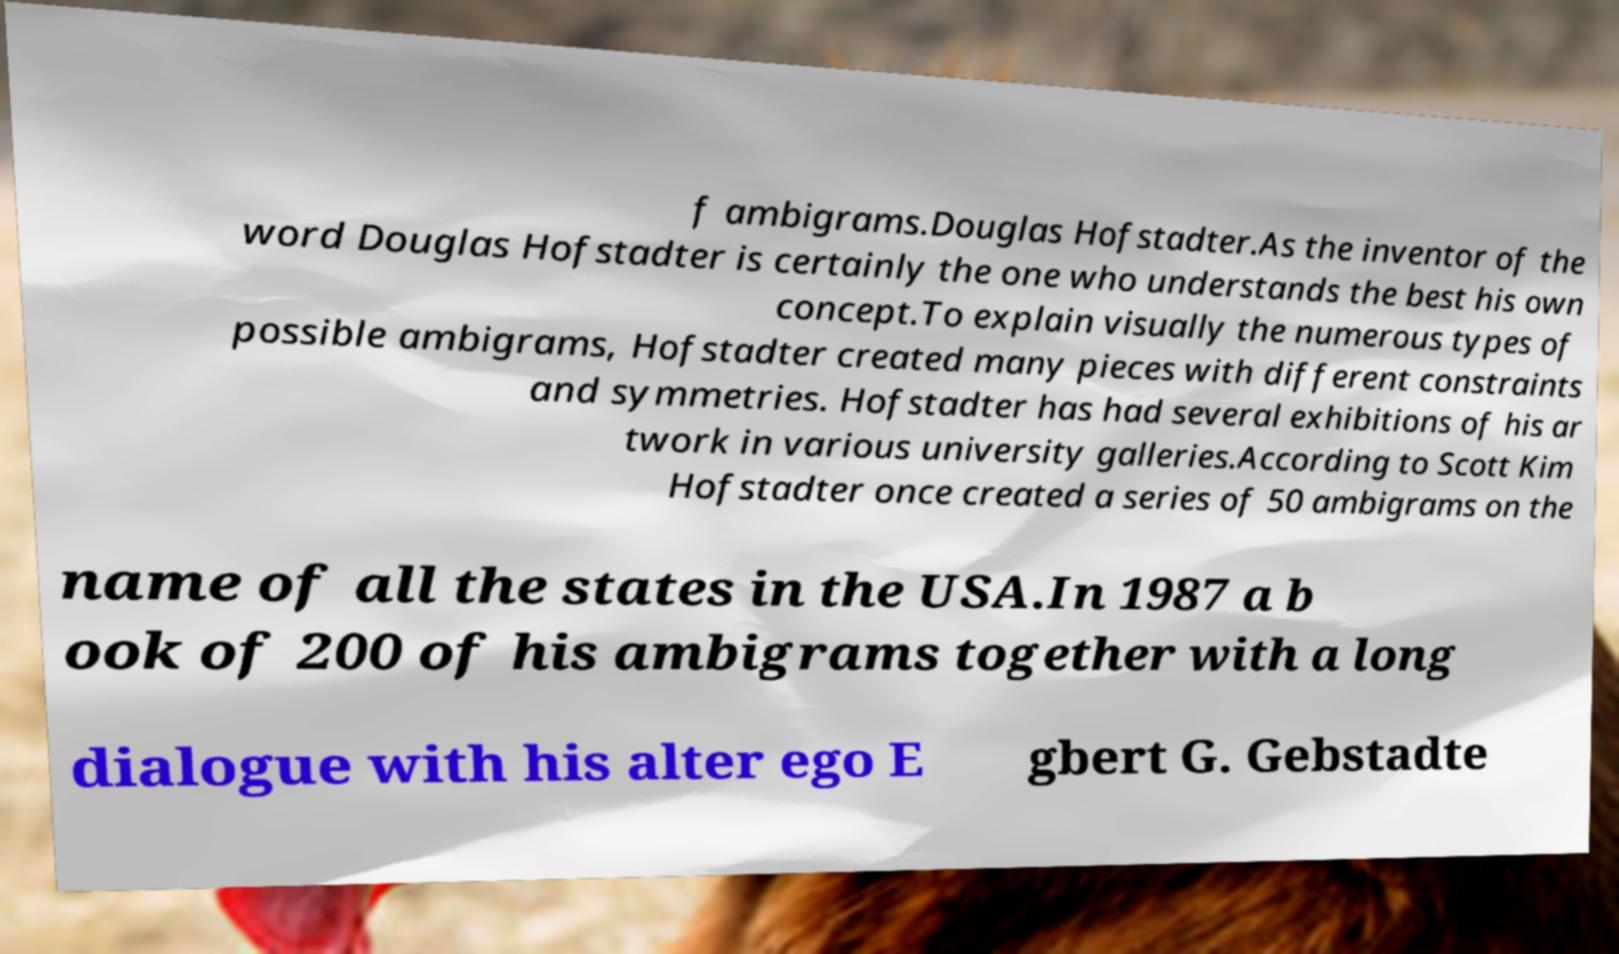I need the written content from this picture converted into text. Can you do that? f ambigrams.Douglas Hofstadter.As the inventor of the word Douglas Hofstadter is certainly the one who understands the best his own concept.To explain visually the numerous types of possible ambigrams, Hofstadter created many pieces with different constraints and symmetries. Hofstadter has had several exhibitions of his ar twork in various university galleries.According to Scott Kim Hofstadter once created a series of 50 ambigrams on the name of all the states in the USA.In 1987 a b ook of 200 of his ambigrams together with a long dialogue with his alter ego E gbert G. Gebstadte 